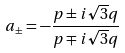<formula> <loc_0><loc_0><loc_500><loc_500>a _ { \pm } = - \frac { p \pm i \sqrt { 3 } q } { p \mp i \sqrt { 3 } q }</formula> 